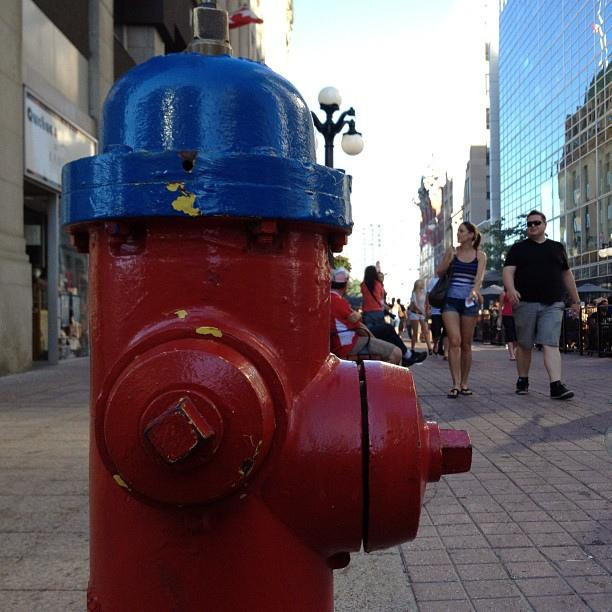What cannot be done in front of this object? park 